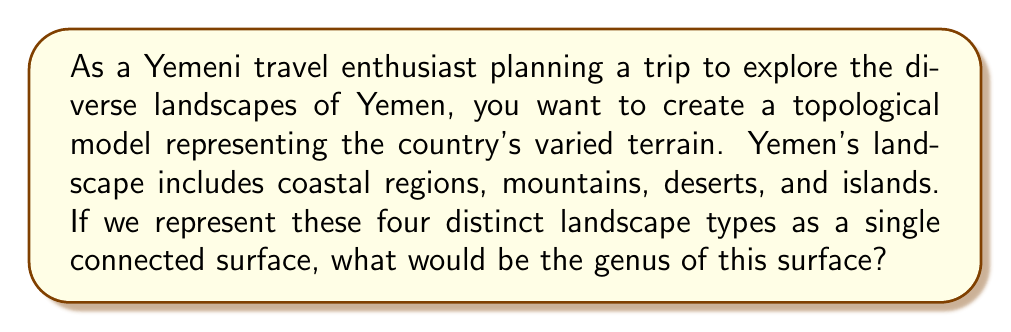Give your solution to this math problem. To solve this problem, we need to understand the concept of genus in topology and how it relates to the diverse landscapes of Yemen.

1. In topology, the genus of a surface is the number of "handles" or "holes" it has. For example, a sphere has genus 0, while a torus (donut shape) has genus 1.

2. To represent Yemen's diverse landscapes as a single connected surface, we need to consider how these landscapes are connected:
   - Coastal regions
   - Mountains
   - Deserts
   - Islands

3. We can represent this as a sphere (the main landmass) with additional handles for each distinct landscape type that's not directly connected to the others.

4. The coastal regions, mountains, and deserts can be considered as part of the main landmass (sphere). However, the islands are separate and need to be connected to the main landmass.

5. To connect the islands to the main landmass without intersecting the surface, we need to add one handle (or hole) for each island group.

6. Yemen has two main island groups: the Socotra Archipelago and the Hanish Islands.

7. Therefore, we need to add two handles to our sphere to represent these island groups.

8. The genus of a sphere is 0, and we're adding 2 handles.

9. The formula for the genus of the resulting surface is:

   $$g = g_{sphere} + \text{number of handles}$$

   $$g = 0 + 2 = 2$$

Thus, the genus of the surface representing Yemen's diverse landscapes is 2.
Answer: The genus of the surface representing Yemen's diverse landscapes is 2. 